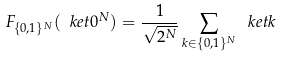<formula> <loc_0><loc_0><loc_500><loc_500>F _ { \{ 0 , 1 \} ^ { N } } ( \ k e t 0 ^ { N } ) = \frac { 1 } { \sqrt { 2 ^ { N } } } \sum _ { k \in \{ 0 , 1 \} ^ { N } } \ k e t k</formula> 